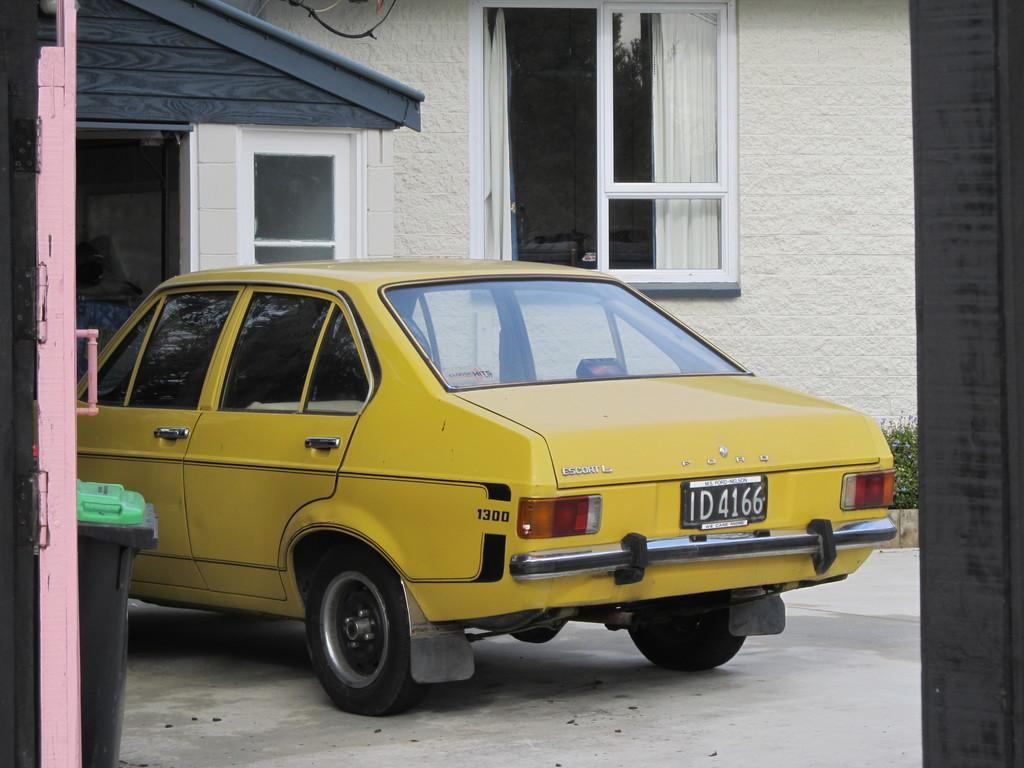What type of structure is visible in the image? There is a building in the image. Can you identify any specific features of the building? There is a door in the image. What else can be seen on the ground in the image? There is a dustbin and a car on the ground in the image. Are there any natural elements present in the image? Yes, there is a plant with flowers in the image. Can you describe any man-made objects in the image that are not part of the building? There is a wire in the image. What type of heart can be seen beating inside the building in the image? There is no heart visible inside the building in the image. 